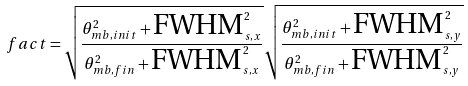Convert formula to latex. <formula><loc_0><loc_0><loc_500><loc_500>f a c t = \sqrt { \frac { \theta _ { m b , i n i t } ^ { 2 } + \text {FWHM} _ { s , x } ^ { 2 } } { \theta _ { m b , f i n } ^ { 2 } + \text {FWHM} _ { s , x } ^ { 2 } } } \sqrt { \frac { \theta _ { m b , i n i t } ^ { 2 } + \text {FWHM} _ { s , y } ^ { 2 } } { \theta _ { m b , f i n } ^ { 2 } + \text {FWHM} _ { s , y } ^ { 2 } } }</formula> 